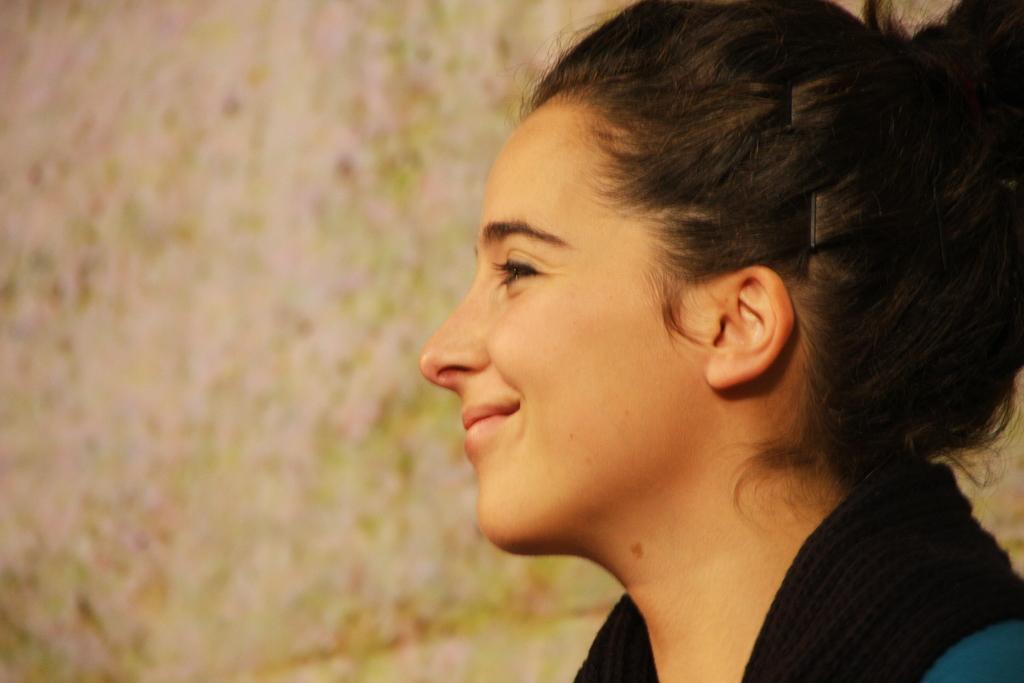Please provide a concise description of this image. Here in this picture we can see a woman present over there and we can see she is smiling. 